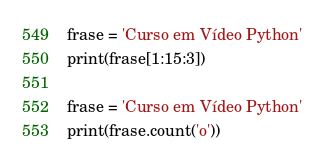<code> <loc_0><loc_0><loc_500><loc_500><_Python_>frase = 'Curso em Vídeo Python'
print(frase[1:15:3])

frase = 'Curso em Vídeo Python'
print(frase.count('o'))
</code> 